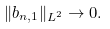<formula> <loc_0><loc_0><loc_500><loc_500>\| b _ { n , 1 } \| _ { L ^ { 2 } } \to 0 .</formula> 